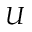Convert formula to latex. <formula><loc_0><loc_0><loc_500><loc_500>U</formula> 